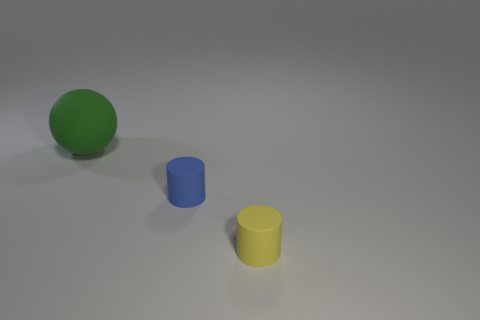Are there any other things that are the same size as the ball?
Provide a short and direct response. No. The big ball that is the same material as the small yellow cylinder is what color?
Make the answer very short. Green. There is a rubber object on the left side of the blue matte cylinder; does it have the same size as the small blue matte thing?
Your answer should be very brief. No. What number of things are tiny blue matte cylinders or large purple rubber blocks?
Provide a succinct answer. 1. The cylinder that is in front of the cylinder behind the small matte cylinder in front of the small blue object is made of what material?
Offer a very short reply. Rubber. There is a tiny object that is on the left side of the tiny yellow cylinder; what is it made of?
Provide a short and direct response. Rubber. Is there a green matte ball of the same size as the yellow matte object?
Provide a short and direct response. No. How many cyan things are big things or cylinders?
Keep it short and to the point. 0. How many other rubber things have the same color as the large object?
Give a very brief answer. 0. Is the material of the big green thing the same as the blue cylinder?
Give a very brief answer. Yes. 